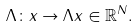Convert formula to latex. <formula><loc_0><loc_0><loc_500><loc_500>\Lambda \colon x \rightarrow \Lambda x \in { \mathbb { R } } ^ { N } .</formula> 